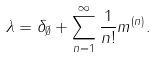Convert formula to latex. <formula><loc_0><loc_0><loc_500><loc_500>\lambda = \delta _ { \emptyset } + \sum _ { n = 1 } ^ { \infty } \frac { 1 } { n ! } m ^ { ( n ) } .</formula> 